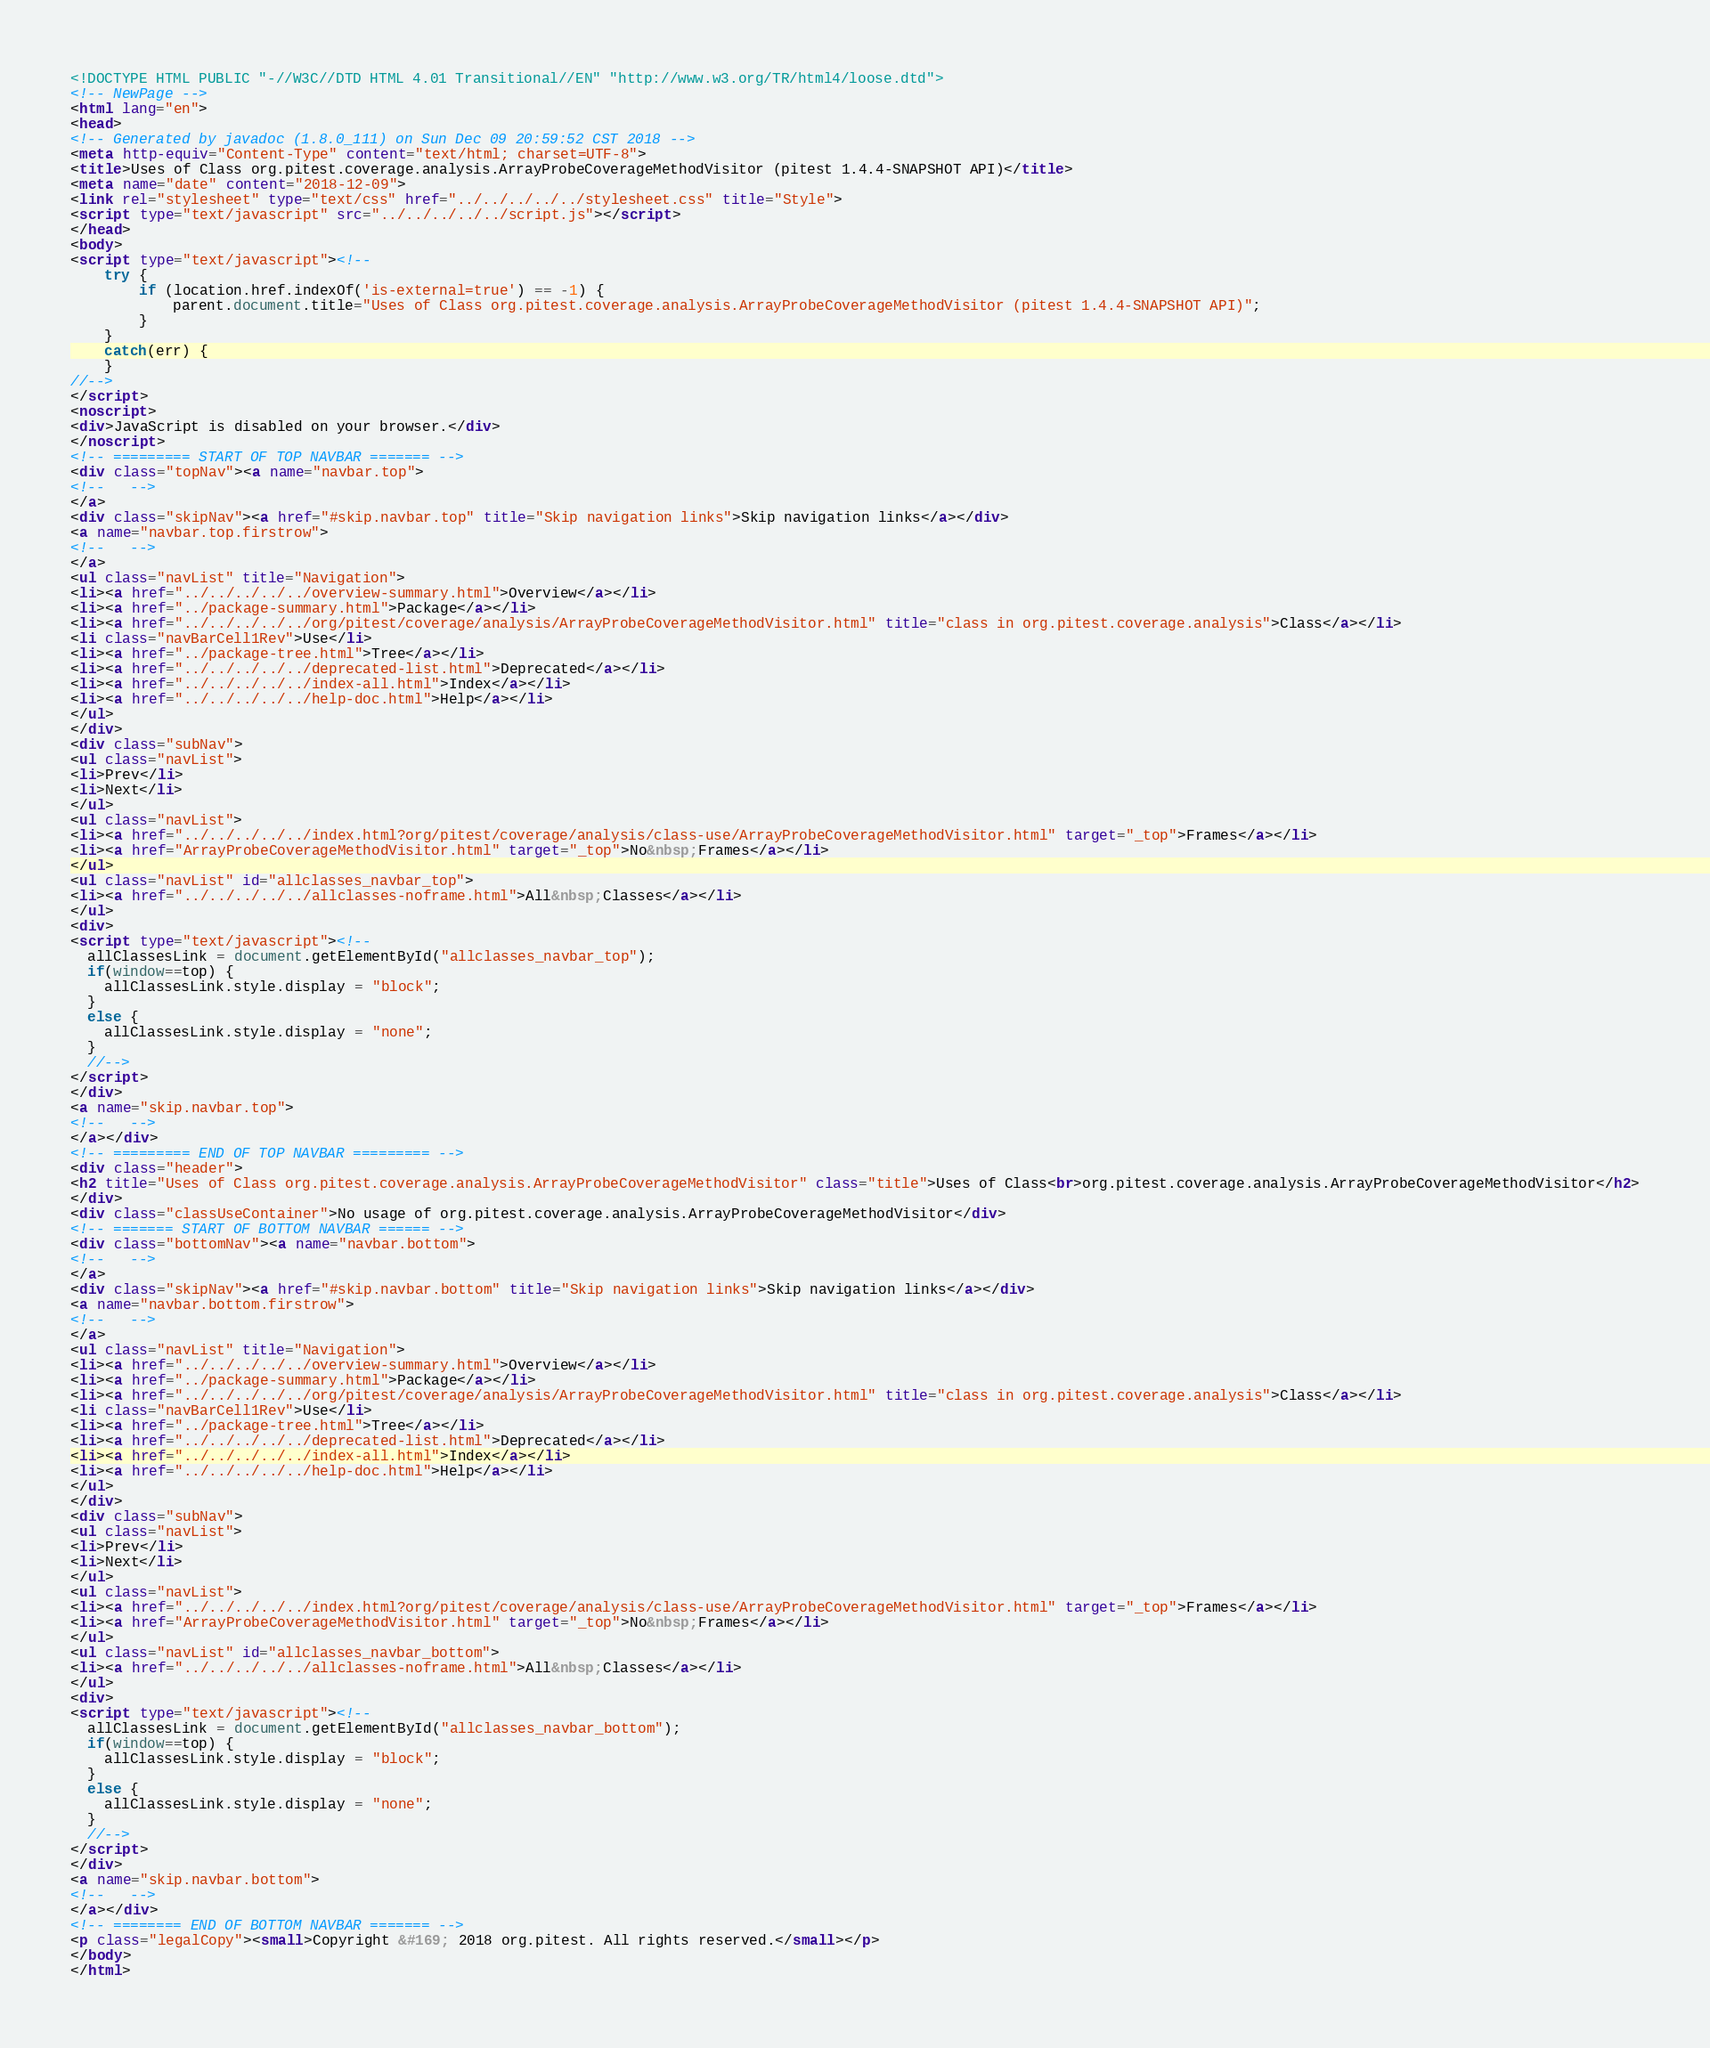<code> <loc_0><loc_0><loc_500><loc_500><_HTML_><!DOCTYPE HTML PUBLIC "-//W3C//DTD HTML 4.01 Transitional//EN" "http://www.w3.org/TR/html4/loose.dtd">
<!-- NewPage -->
<html lang="en">
<head>
<!-- Generated by javadoc (1.8.0_111) on Sun Dec 09 20:59:52 CST 2018 -->
<meta http-equiv="Content-Type" content="text/html; charset=UTF-8">
<title>Uses of Class org.pitest.coverage.analysis.ArrayProbeCoverageMethodVisitor (pitest 1.4.4-SNAPSHOT API)</title>
<meta name="date" content="2018-12-09">
<link rel="stylesheet" type="text/css" href="../../../../../stylesheet.css" title="Style">
<script type="text/javascript" src="../../../../../script.js"></script>
</head>
<body>
<script type="text/javascript"><!--
    try {
        if (location.href.indexOf('is-external=true') == -1) {
            parent.document.title="Uses of Class org.pitest.coverage.analysis.ArrayProbeCoverageMethodVisitor (pitest 1.4.4-SNAPSHOT API)";
        }
    }
    catch(err) {
    }
//-->
</script>
<noscript>
<div>JavaScript is disabled on your browser.</div>
</noscript>
<!-- ========= START OF TOP NAVBAR ======= -->
<div class="topNav"><a name="navbar.top">
<!--   -->
</a>
<div class="skipNav"><a href="#skip.navbar.top" title="Skip navigation links">Skip navigation links</a></div>
<a name="navbar.top.firstrow">
<!--   -->
</a>
<ul class="navList" title="Navigation">
<li><a href="../../../../../overview-summary.html">Overview</a></li>
<li><a href="../package-summary.html">Package</a></li>
<li><a href="../../../../../org/pitest/coverage/analysis/ArrayProbeCoverageMethodVisitor.html" title="class in org.pitest.coverage.analysis">Class</a></li>
<li class="navBarCell1Rev">Use</li>
<li><a href="../package-tree.html">Tree</a></li>
<li><a href="../../../../../deprecated-list.html">Deprecated</a></li>
<li><a href="../../../../../index-all.html">Index</a></li>
<li><a href="../../../../../help-doc.html">Help</a></li>
</ul>
</div>
<div class="subNav">
<ul class="navList">
<li>Prev</li>
<li>Next</li>
</ul>
<ul class="navList">
<li><a href="../../../../../index.html?org/pitest/coverage/analysis/class-use/ArrayProbeCoverageMethodVisitor.html" target="_top">Frames</a></li>
<li><a href="ArrayProbeCoverageMethodVisitor.html" target="_top">No&nbsp;Frames</a></li>
</ul>
<ul class="navList" id="allclasses_navbar_top">
<li><a href="../../../../../allclasses-noframe.html">All&nbsp;Classes</a></li>
</ul>
<div>
<script type="text/javascript"><!--
  allClassesLink = document.getElementById("allclasses_navbar_top");
  if(window==top) {
    allClassesLink.style.display = "block";
  }
  else {
    allClassesLink.style.display = "none";
  }
  //-->
</script>
</div>
<a name="skip.navbar.top">
<!--   -->
</a></div>
<!-- ========= END OF TOP NAVBAR ========= -->
<div class="header">
<h2 title="Uses of Class org.pitest.coverage.analysis.ArrayProbeCoverageMethodVisitor" class="title">Uses of Class<br>org.pitest.coverage.analysis.ArrayProbeCoverageMethodVisitor</h2>
</div>
<div class="classUseContainer">No usage of org.pitest.coverage.analysis.ArrayProbeCoverageMethodVisitor</div>
<!-- ======= START OF BOTTOM NAVBAR ====== -->
<div class="bottomNav"><a name="navbar.bottom">
<!--   -->
</a>
<div class="skipNav"><a href="#skip.navbar.bottom" title="Skip navigation links">Skip navigation links</a></div>
<a name="navbar.bottom.firstrow">
<!--   -->
</a>
<ul class="navList" title="Navigation">
<li><a href="../../../../../overview-summary.html">Overview</a></li>
<li><a href="../package-summary.html">Package</a></li>
<li><a href="../../../../../org/pitest/coverage/analysis/ArrayProbeCoverageMethodVisitor.html" title="class in org.pitest.coverage.analysis">Class</a></li>
<li class="navBarCell1Rev">Use</li>
<li><a href="../package-tree.html">Tree</a></li>
<li><a href="../../../../../deprecated-list.html">Deprecated</a></li>
<li><a href="../../../../../index-all.html">Index</a></li>
<li><a href="../../../../../help-doc.html">Help</a></li>
</ul>
</div>
<div class="subNav">
<ul class="navList">
<li>Prev</li>
<li>Next</li>
</ul>
<ul class="navList">
<li><a href="../../../../../index.html?org/pitest/coverage/analysis/class-use/ArrayProbeCoverageMethodVisitor.html" target="_top">Frames</a></li>
<li><a href="ArrayProbeCoverageMethodVisitor.html" target="_top">No&nbsp;Frames</a></li>
</ul>
<ul class="navList" id="allclasses_navbar_bottom">
<li><a href="../../../../../allclasses-noframe.html">All&nbsp;Classes</a></li>
</ul>
<div>
<script type="text/javascript"><!--
  allClassesLink = document.getElementById("allclasses_navbar_bottom");
  if(window==top) {
    allClassesLink.style.display = "block";
  }
  else {
    allClassesLink.style.display = "none";
  }
  //-->
</script>
</div>
<a name="skip.navbar.bottom">
<!--   -->
</a></div>
<!-- ======== END OF BOTTOM NAVBAR ======= -->
<p class="legalCopy"><small>Copyright &#169; 2018 org.pitest. All rights reserved.</small></p>
</body>
</html>
</code> 